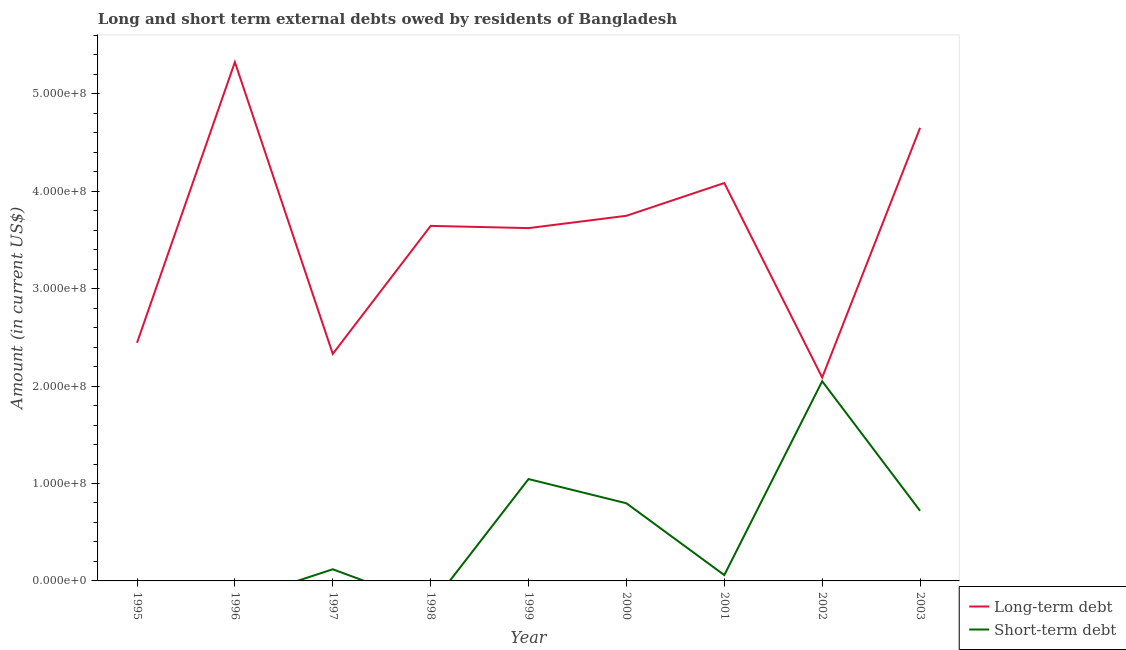How many different coloured lines are there?
Keep it short and to the point. 2. Is the number of lines equal to the number of legend labels?
Provide a succinct answer. No. What is the short-term debts owed by residents in 2003?
Offer a terse response. 7.20e+07. Across all years, what is the maximum long-term debts owed by residents?
Offer a very short reply. 5.33e+08. In which year was the long-term debts owed by residents maximum?
Ensure brevity in your answer.  1996. What is the total short-term debts owed by residents in the graph?
Offer a very short reply. 4.79e+08. What is the difference between the short-term debts owed by residents in 1997 and that in 2001?
Make the answer very short. 5.96e+06. What is the difference between the long-term debts owed by residents in 1998 and the short-term debts owed by residents in 2000?
Give a very brief answer. 2.85e+08. What is the average long-term debts owed by residents per year?
Your response must be concise. 3.55e+08. In the year 2001, what is the difference between the short-term debts owed by residents and long-term debts owed by residents?
Provide a succinct answer. -4.03e+08. In how many years, is the short-term debts owed by residents greater than 340000000 US$?
Offer a very short reply. 0. What is the ratio of the long-term debts owed by residents in 1998 to that in 2000?
Offer a terse response. 0.97. Is the short-term debts owed by residents in 1997 less than that in 2000?
Your answer should be very brief. Yes. What is the difference between the highest and the second highest short-term debts owed by residents?
Your answer should be very brief. 1.00e+08. What is the difference between the highest and the lowest long-term debts owed by residents?
Offer a terse response. 3.24e+08. In how many years, is the long-term debts owed by residents greater than the average long-term debts owed by residents taken over all years?
Give a very brief answer. 6. Is the sum of the long-term debts owed by residents in 1998 and 2001 greater than the maximum short-term debts owed by residents across all years?
Your response must be concise. Yes. Does the long-term debts owed by residents monotonically increase over the years?
Provide a succinct answer. No. How many lines are there?
Your response must be concise. 2. How many years are there in the graph?
Make the answer very short. 9. What is the difference between two consecutive major ticks on the Y-axis?
Make the answer very short. 1.00e+08. Are the values on the major ticks of Y-axis written in scientific E-notation?
Your answer should be compact. Yes. Does the graph contain any zero values?
Keep it short and to the point. Yes. Does the graph contain grids?
Provide a short and direct response. No. How are the legend labels stacked?
Your answer should be very brief. Vertical. What is the title of the graph?
Provide a short and direct response. Long and short term external debts owed by residents of Bangladesh. What is the label or title of the Y-axis?
Provide a short and direct response. Amount (in current US$). What is the Amount (in current US$) of Long-term debt in 1995?
Your response must be concise. 2.44e+08. What is the Amount (in current US$) of Short-term debt in 1995?
Make the answer very short. 0. What is the Amount (in current US$) in Long-term debt in 1996?
Keep it short and to the point. 5.33e+08. What is the Amount (in current US$) of Short-term debt in 1996?
Make the answer very short. 0. What is the Amount (in current US$) in Long-term debt in 1997?
Your answer should be compact. 2.33e+08. What is the Amount (in current US$) in Short-term debt in 1997?
Your answer should be very brief. 1.20e+07. What is the Amount (in current US$) in Long-term debt in 1998?
Provide a succinct answer. 3.65e+08. What is the Amount (in current US$) in Short-term debt in 1998?
Your response must be concise. 0. What is the Amount (in current US$) of Long-term debt in 1999?
Your answer should be very brief. 3.62e+08. What is the Amount (in current US$) of Short-term debt in 1999?
Ensure brevity in your answer.  1.05e+08. What is the Amount (in current US$) in Long-term debt in 2000?
Ensure brevity in your answer.  3.75e+08. What is the Amount (in current US$) in Short-term debt in 2000?
Keep it short and to the point. 7.97e+07. What is the Amount (in current US$) of Long-term debt in 2001?
Ensure brevity in your answer.  4.09e+08. What is the Amount (in current US$) of Short-term debt in 2001?
Provide a succinct answer. 6.00e+06. What is the Amount (in current US$) in Long-term debt in 2002?
Your response must be concise. 2.09e+08. What is the Amount (in current US$) of Short-term debt in 2002?
Provide a succinct answer. 2.05e+08. What is the Amount (in current US$) in Long-term debt in 2003?
Provide a short and direct response. 4.65e+08. What is the Amount (in current US$) of Short-term debt in 2003?
Your answer should be very brief. 7.20e+07. Across all years, what is the maximum Amount (in current US$) in Long-term debt?
Your answer should be very brief. 5.33e+08. Across all years, what is the maximum Amount (in current US$) in Short-term debt?
Offer a very short reply. 2.05e+08. Across all years, what is the minimum Amount (in current US$) in Long-term debt?
Provide a succinct answer. 2.09e+08. What is the total Amount (in current US$) in Long-term debt in the graph?
Your answer should be very brief. 3.19e+09. What is the total Amount (in current US$) of Short-term debt in the graph?
Offer a very short reply. 4.79e+08. What is the difference between the Amount (in current US$) of Long-term debt in 1995 and that in 1996?
Provide a succinct answer. -2.88e+08. What is the difference between the Amount (in current US$) in Long-term debt in 1995 and that in 1997?
Provide a short and direct response. 1.14e+07. What is the difference between the Amount (in current US$) in Long-term debt in 1995 and that in 1998?
Your answer should be compact. -1.20e+08. What is the difference between the Amount (in current US$) in Long-term debt in 1995 and that in 1999?
Ensure brevity in your answer.  -1.18e+08. What is the difference between the Amount (in current US$) in Long-term debt in 1995 and that in 2000?
Offer a very short reply. -1.30e+08. What is the difference between the Amount (in current US$) of Long-term debt in 1995 and that in 2001?
Your answer should be compact. -1.64e+08. What is the difference between the Amount (in current US$) of Long-term debt in 1995 and that in 2002?
Your response must be concise. 3.57e+07. What is the difference between the Amount (in current US$) of Long-term debt in 1995 and that in 2003?
Ensure brevity in your answer.  -2.21e+08. What is the difference between the Amount (in current US$) of Long-term debt in 1996 and that in 1997?
Offer a terse response. 3.00e+08. What is the difference between the Amount (in current US$) of Long-term debt in 1996 and that in 1998?
Ensure brevity in your answer.  1.68e+08. What is the difference between the Amount (in current US$) of Long-term debt in 1996 and that in 1999?
Provide a short and direct response. 1.70e+08. What is the difference between the Amount (in current US$) in Long-term debt in 1996 and that in 2000?
Your answer should be compact. 1.58e+08. What is the difference between the Amount (in current US$) of Long-term debt in 1996 and that in 2001?
Give a very brief answer. 1.24e+08. What is the difference between the Amount (in current US$) of Long-term debt in 1996 and that in 2002?
Keep it short and to the point. 3.24e+08. What is the difference between the Amount (in current US$) in Long-term debt in 1996 and that in 2003?
Ensure brevity in your answer.  6.76e+07. What is the difference between the Amount (in current US$) of Long-term debt in 1997 and that in 1998?
Keep it short and to the point. -1.31e+08. What is the difference between the Amount (in current US$) of Long-term debt in 1997 and that in 1999?
Your response must be concise. -1.29e+08. What is the difference between the Amount (in current US$) in Short-term debt in 1997 and that in 1999?
Provide a short and direct response. -9.26e+07. What is the difference between the Amount (in current US$) of Long-term debt in 1997 and that in 2000?
Ensure brevity in your answer.  -1.42e+08. What is the difference between the Amount (in current US$) in Short-term debt in 1997 and that in 2000?
Offer a very short reply. -6.78e+07. What is the difference between the Amount (in current US$) of Long-term debt in 1997 and that in 2001?
Keep it short and to the point. -1.75e+08. What is the difference between the Amount (in current US$) in Short-term debt in 1997 and that in 2001?
Offer a very short reply. 5.96e+06. What is the difference between the Amount (in current US$) in Long-term debt in 1997 and that in 2002?
Offer a terse response. 2.43e+07. What is the difference between the Amount (in current US$) of Short-term debt in 1997 and that in 2002?
Provide a succinct answer. -1.93e+08. What is the difference between the Amount (in current US$) in Long-term debt in 1997 and that in 2003?
Keep it short and to the point. -2.32e+08. What is the difference between the Amount (in current US$) in Short-term debt in 1997 and that in 2003?
Make the answer very short. -6.00e+07. What is the difference between the Amount (in current US$) in Long-term debt in 1998 and that in 1999?
Your response must be concise. 2.29e+06. What is the difference between the Amount (in current US$) in Long-term debt in 1998 and that in 2000?
Provide a short and direct response. -1.04e+07. What is the difference between the Amount (in current US$) of Long-term debt in 1998 and that in 2001?
Offer a terse response. -4.40e+07. What is the difference between the Amount (in current US$) in Long-term debt in 1998 and that in 2002?
Offer a very short reply. 1.56e+08. What is the difference between the Amount (in current US$) of Long-term debt in 1998 and that in 2003?
Make the answer very short. -1.01e+08. What is the difference between the Amount (in current US$) in Long-term debt in 1999 and that in 2000?
Your response must be concise. -1.26e+07. What is the difference between the Amount (in current US$) of Short-term debt in 1999 and that in 2000?
Offer a terse response. 2.49e+07. What is the difference between the Amount (in current US$) of Long-term debt in 1999 and that in 2001?
Your answer should be compact. -4.63e+07. What is the difference between the Amount (in current US$) of Short-term debt in 1999 and that in 2001?
Your response must be concise. 9.86e+07. What is the difference between the Amount (in current US$) in Long-term debt in 1999 and that in 2002?
Keep it short and to the point. 1.53e+08. What is the difference between the Amount (in current US$) of Short-term debt in 1999 and that in 2002?
Your answer should be compact. -1.00e+08. What is the difference between the Amount (in current US$) in Long-term debt in 1999 and that in 2003?
Provide a succinct answer. -1.03e+08. What is the difference between the Amount (in current US$) in Short-term debt in 1999 and that in 2003?
Provide a succinct answer. 3.26e+07. What is the difference between the Amount (in current US$) in Long-term debt in 2000 and that in 2001?
Provide a succinct answer. -3.36e+07. What is the difference between the Amount (in current US$) of Short-term debt in 2000 and that in 2001?
Make the answer very short. 7.37e+07. What is the difference between the Amount (in current US$) of Long-term debt in 2000 and that in 2002?
Your answer should be compact. 1.66e+08. What is the difference between the Amount (in current US$) of Short-term debt in 2000 and that in 2002?
Make the answer very short. -1.25e+08. What is the difference between the Amount (in current US$) in Long-term debt in 2000 and that in 2003?
Ensure brevity in your answer.  -9.03e+07. What is the difference between the Amount (in current US$) of Short-term debt in 2000 and that in 2003?
Your response must be concise. 7.71e+06. What is the difference between the Amount (in current US$) in Long-term debt in 2001 and that in 2002?
Provide a succinct answer. 2.00e+08. What is the difference between the Amount (in current US$) of Short-term debt in 2001 and that in 2002?
Provide a succinct answer. -1.99e+08. What is the difference between the Amount (in current US$) in Long-term debt in 2001 and that in 2003?
Offer a very short reply. -5.66e+07. What is the difference between the Amount (in current US$) in Short-term debt in 2001 and that in 2003?
Provide a succinct answer. -6.60e+07. What is the difference between the Amount (in current US$) of Long-term debt in 2002 and that in 2003?
Offer a very short reply. -2.56e+08. What is the difference between the Amount (in current US$) of Short-term debt in 2002 and that in 2003?
Make the answer very short. 1.33e+08. What is the difference between the Amount (in current US$) of Long-term debt in 1995 and the Amount (in current US$) of Short-term debt in 1997?
Give a very brief answer. 2.33e+08. What is the difference between the Amount (in current US$) in Long-term debt in 1995 and the Amount (in current US$) in Short-term debt in 1999?
Make the answer very short. 1.40e+08. What is the difference between the Amount (in current US$) in Long-term debt in 1995 and the Amount (in current US$) in Short-term debt in 2000?
Give a very brief answer. 1.65e+08. What is the difference between the Amount (in current US$) in Long-term debt in 1995 and the Amount (in current US$) in Short-term debt in 2001?
Ensure brevity in your answer.  2.38e+08. What is the difference between the Amount (in current US$) in Long-term debt in 1995 and the Amount (in current US$) in Short-term debt in 2002?
Your response must be concise. 3.95e+07. What is the difference between the Amount (in current US$) in Long-term debt in 1995 and the Amount (in current US$) in Short-term debt in 2003?
Your answer should be compact. 1.72e+08. What is the difference between the Amount (in current US$) in Long-term debt in 1996 and the Amount (in current US$) in Short-term debt in 1997?
Ensure brevity in your answer.  5.21e+08. What is the difference between the Amount (in current US$) of Long-term debt in 1996 and the Amount (in current US$) of Short-term debt in 1999?
Your answer should be compact. 4.28e+08. What is the difference between the Amount (in current US$) in Long-term debt in 1996 and the Amount (in current US$) in Short-term debt in 2000?
Offer a terse response. 4.53e+08. What is the difference between the Amount (in current US$) of Long-term debt in 1996 and the Amount (in current US$) of Short-term debt in 2001?
Give a very brief answer. 5.27e+08. What is the difference between the Amount (in current US$) in Long-term debt in 1996 and the Amount (in current US$) in Short-term debt in 2002?
Offer a very short reply. 3.28e+08. What is the difference between the Amount (in current US$) in Long-term debt in 1996 and the Amount (in current US$) in Short-term debt in 2003?
Your answer should be compact. 4.61e+08. What is the difference between the Amount (in current US$) in Long-term debt in 1997 and the Amount (in current US$) in Short-term debt in 1999?
Offer a terse response. 1.29e+08. What is the difference between the Amount (in current US$) of Long-term debt in 1997 and the Amount (in current US$) of Short-term debt in 2000?
Provide a short and direct response. 1.53e+08. What is the difference between the Amount (in current US$) in Long-term debt in 1997 and the Amount (in current US$) in Short-term debt in 2001?
Offer a very short reply. 2.27e+08. What is the difference between the Amount (in current US$) of Long-term debt in 1997 and the Amount (in current US$) of Short-term debt in 2002?
Make the answer very short. 2.81e+07. What is the difference between the Amount (in current US$) of Long-term debt in 1997 and the Amount (in current US$) of Short-term debt in 2003?
Your response must be concise. 1.61e+08. What is the difference between the Amount (in current US$) in Long-term debt in 1998 and the Amount (in current US$) in Short-term debt in 1999?
Offer a terse response. 2.60e+08. What is the difference between the Amount (in current US$) in Long-term debt in 1998 and the Amount (in current US$) in Short-term debt in 2000?
Your response must be concise. 2.85e+08. What is the difference between the Amount (in current US$) of Long-term debt in 1998 and the Amount (in current US$) of Short-term debt in 2001?
Ensure brevity in your answer.  3.59e+08. What is the difference between the Amount (in current US$) of Long-term debt in 1998 and the Amount (in current US$) of Short-term debt in 2002?
Your answer should be very brief. 1.60e+08. What is the difference between the Amount (in current US$) in Long-term debt in 1998 and the Amount (in current US$) in Short-term debt in 2003?
Make the answer very short. 2.93e+08. What is the difference between the Amount (in current US$) in Long-term debt in 1999 and the Amount (in current US$) in Short-term debt in 2000?
Provide a succinct answer. 2.83e+08. What is the difference between the Amount (in current US$) in Long-term debt in 1999 and the Amount (in current US$) in Short-term debt in 2001?
Your response must be concise. 3.56e+08. What is the difference between the Amount (in current US$) of Long-term debt in 1999 and the Amount (in current US$) of Short-term debt in 2002?
Provide a short and direct response. 1.57e+08. What is the difference between the Amount (in current US$) in Long-term debt in 1999 and the Amount (in current US$) in Short-term debt in 2003?
Give a very brief answer. 2.90e+08. What is the difference between the Amount (in current US$) in Long-term debt in 2000 and the Amount (in current US$) in Short-term debt in 2001?
Ensure brevity in your answer.  3.69e+08. What is the difference between the Amount (in current US$) of Long-term debt in 2000 and the Amount (in current US$) of Short-term debt in 2002?
Ensure brevity in your answer.  1.70e+08. What is the difference between the Amount (in current US$) in Long-term debt in 2000 and the Amount (in current US$) in Short-term debt in 2003?
Your response must be concise. 3.03e+08. What is the difference between the Amount (in current US$) of Long-term debt in 2001 and the Amount (in current US$) of Short-term debt in 2002?
Provide a short and direct response. 2.04e+08. What is the difference between the Amount (in current US$) in Long-term debt in 2001 and the Amount (in current US$) in Short-term debt in 2003?
Your response must be concise. 3.37e+08. What is the difference between the Amount (in current US$) in Long-term debt in 2002 and the Amount (in current US$) in Short-term debt in 2003?
Keep it short and to the point. 1.37e+08. What is the average Amount (in current US$) in Long-term debt per year?
Ensure brevity in your answer.  3.55e+08. What is the average Amount (in current US$) in Short-term debt per year?
Keep it short and to the point. 5.32e+07. In the year 1997, what is the difference between the Amount (in current US$) of Long-term debt and Amount (in current US$) of Short-term debt?
Provide a succinct answer. 2.21e+08. In the year 1999, what is the difference between the Amount (in current US$) of Long-term debt and Amount (in current US$) of Short-term debt?
Your answer should be compact. 2.58e+08. In the year 2000, what is the difference between the Amount (in current US$) of Long-term debt and Amount (in current US$) of Short-term debt?
Keep it short and to the point. 2.95e+08. In the year 2001, what is the difference between the Amount (in current US$) of Long-term debt and Amount (in current US$) of Short-term debt?
Give a very brief answer. 4.03e+08. In the year 2002, what is the difference between the Amount (in current US$) of Long-term debt and Amount (in current US$) of Short-term debt?
Your response must be concise. 3.79e+06. In the year 2003, what is the difference between the Amount (in current US$) of Long-term debt and Amount (in current US$) of Short-term debt?
Your response must be concise. 3.93e+08. What is the ratio of the Amount (in current US$) of Long-term debt in 1995 to that in 1996?
Provide a succinct answer. 0.46. What is the ratio of the Amount (in current US$) of Long-term debt in 1995 to that in 1997?
Make the answer very short. 1.05. What is the ratio of the Amount (in current US$) of Long-term debt in 1995 to that in 1998?
Give a very brief answer. 0.67. What is the ratio of the Amount (in current US$) in Long-term debt in 1995 to that in 1999?
Ensure brevity in your answer.  0.67. What is the ratio of the Amount (in current US$) of Long-term debt in 1995 to that in 2000?
Give a very brief answer. 0.65. What is the ratio of the Amount (in current US$) in Long-term debt in 1995 to that in 2001?
Your response must be concise. 0.6. What is the ratio of the Amount (in current US$) of Long-term debt in 1995 to that in 2002?
Give a very brief answer. 1.17. What is the ratio of the Amount (in current US$) in Long-term debt in 1995 to that in 2003?
Offer a very short reply. 0.53. What is the ratio of the Amount (in current US$) of Long-term debt in 1996 to that in 1997?
Offer a very short reply. 2.29. What is the ratio of the Amount (in current US$) of Long-term debt in 1996 to that in 1998?
Give a very brief answer. 1.46. What is the ratio of the Amount (in current US$) of Long-term debt in 1996 to that in 1999?
Your answer should be very brief. 1.47. What is the ratio of the Amount (in current US$) of Long-term debt in 1996 to that in 2000?
Offer a terse response. 1.42. What is the ratio of the Amount (in current US$) of Long-term debt in 1996 to that in 2001?
Your answer should be compact. 1.3. What is the ratio of the Amount (in current US$) of Long-term debt in 1996 to that in 2002?
Provide a short and direct response. 2.55. What is the ratio of the Amount (in current US$) in Long-term debt in 1996 to that in 2003?
Provide a succinct answer. 1.15. What is the ratio of the Amount (in current US$) in Long-term debt in 1997 to that in 1998?
Offer a terse response. 0.64. What is the ratio of the Amount (in current US$) in Long-term debt in 1997 to that in 1999?
Your answer should be very brief. 0.64. What is the ratio of the Amount (in current US$) in Short-term debt in 1997 to that in 1999?
Provide a succinct answer. 0.11. What is the ratio of the Amount (in current US$) in Long-term debt in 1997 to that in 2000?
Give a very brief answer. 0.62. What is the ratio of the Amount (in current US$) of Long-term debt in 1997 to that in 2001?
Give a very brief answer. 0.57. What is the ratio of the Amount (in current US$) in Short-term debt in 1997 to that in 2001?
Give a very brief answer. 1.99. What is the ratio of the Amount (in current US$) of Long-term debt in 1997 to that in 2002?
Your answer should be very brief. 1.12. What is the ratio of the Amount (in current US$) of Short-term debt in 1997 to that in 2002?
Offer a very short reply. 0.06. What is the ratio of the Amount (in current US$) of Long-term debt in 1997 to that in 2003?
Your answer should be compact. 0.5. What is the ratio of the Amount (in current US$) in Short-term debt in 1997 to that in 2003?
Provide a short and direct response. 0.17. What is the ratio of the Amount (in current US$) in Long-term debt in 1998 to that in 2000?
Keep it short and to the point. 0.97. What is the ratio of the Amount (in current US$) in Long-term debt in 1998 to that in 2001?
Offer a terse response. 0.89. What is the ratio of the Amount (in current US$) in Long-term debt in 1998 to that in 2002?
Give a very brief answer. 1.75. What is the ratio of the Amount (in current US$) of Long-term debt in 1998 to that in 2003?
Keep it short and to the point. 0.78. What is the ratio of the Amount (in current US$) of Long-term debt in 1999 to that in 2000?
Your response must be concise. 0.97. What is the ratio of the Amount (in current US$) in Short-term debt in 1999 to that in 2000?
Provide a succinct answer. 1.31. What is the ratio of the Amount (in current US$) of Long-term debt in 1999 to that in 2001?
Offer a very short reply. 0.89. What is the ratio of the Amount (in current US$) of Short-term debt in 1999 to that in 2001?
Offer a terse response. 17.43. What is the ratio of the Amount (in current US$) in Long-term debt in 1999 to that in 2002?
Ensure brevity in your answer.  1.73. What is the ratio of the Amount (in current US$) in Short-term debt in 1999 to that in 2002?
Offer a terse response. 0.51. What is the ratio of the Amount (in current US$) in Long-term debt in 1999 to that in 2003?
Ensure brevity in your answer.  0.78. What is the ratio of the Amount (in current US$) in Short-term debt in 1999 to that in 2003?
Provide a succinct answer. 1.45. What is the ratio of the Amount (in current US$) in Long-term debt in 2000 to that in 2001?
Keep it short and to the point. 0.92. What is the ratio of the Amount (in current US$) of Short-term debt in 2000 to that in 2001?
Offer a terse response. 13.29. What is the ratio of the Amount (in current US$) of Long-term debt in 2000 to that in 2002?
Provide a short and direct response. 1.8. What is the ratio of the Amount (in current US$) in Short-term debt in 2000 to that in 2002?
Give a very brief answer. 0.39. What is the ratio of the Amount (in current US$) of Long-term debt in 2000 to that in 2003?
Your answer should be very brief. 0.81. What is the ratio of the Amount (in current US$) of Short-term debt in 2000 to that in 2003?
Your answer should be very brief. 1.11. What is the ratio of the Amount (in current US$) in Long-term debt in 2001 to that in 2002?
Provide a short and direct response. 1.96. What is the ratio of the Amount (in current US$) in Short-term debt in 2001 to that in 2002?
Offer a very short reply. 0.03. What is the ratio of the Amount (in current US$) of Long-term debt in 2001 to that in 2003?
Provide a short and direct response. 0.88. What is the ratio of the Amount (in current US$) of Short-term debt in 2001 to that in 2003?
Make the answer very short. 0.08. What is the ratio of the Amount (in current US$) of Long-term debt in 2002 to that in 2003?
Give a very brief answer. 0.45. What is the ratio of the Amount (in current US$) of Short-term debt in 2002 to that in 2003?
Keep it short and to the point. 2.85. What is the difference between the highest and the second highest Amount (in current US$) in Long-term debt?
Offer a terse response. 6.76e+07. What is the difference between the highest and the second highest Amount (in current US$) of Short-term debt?
Offer a very short reply. 1.00e+08. What is the difference between the highest and the lowest Amount (in current US$) in Long-term debt?
Offer a terse response. 3.24e+08. What is the difference between the highest and the lowest Amount (in current US$) in Short-term debt?
Your answer should be compact. 2.05e+08. 